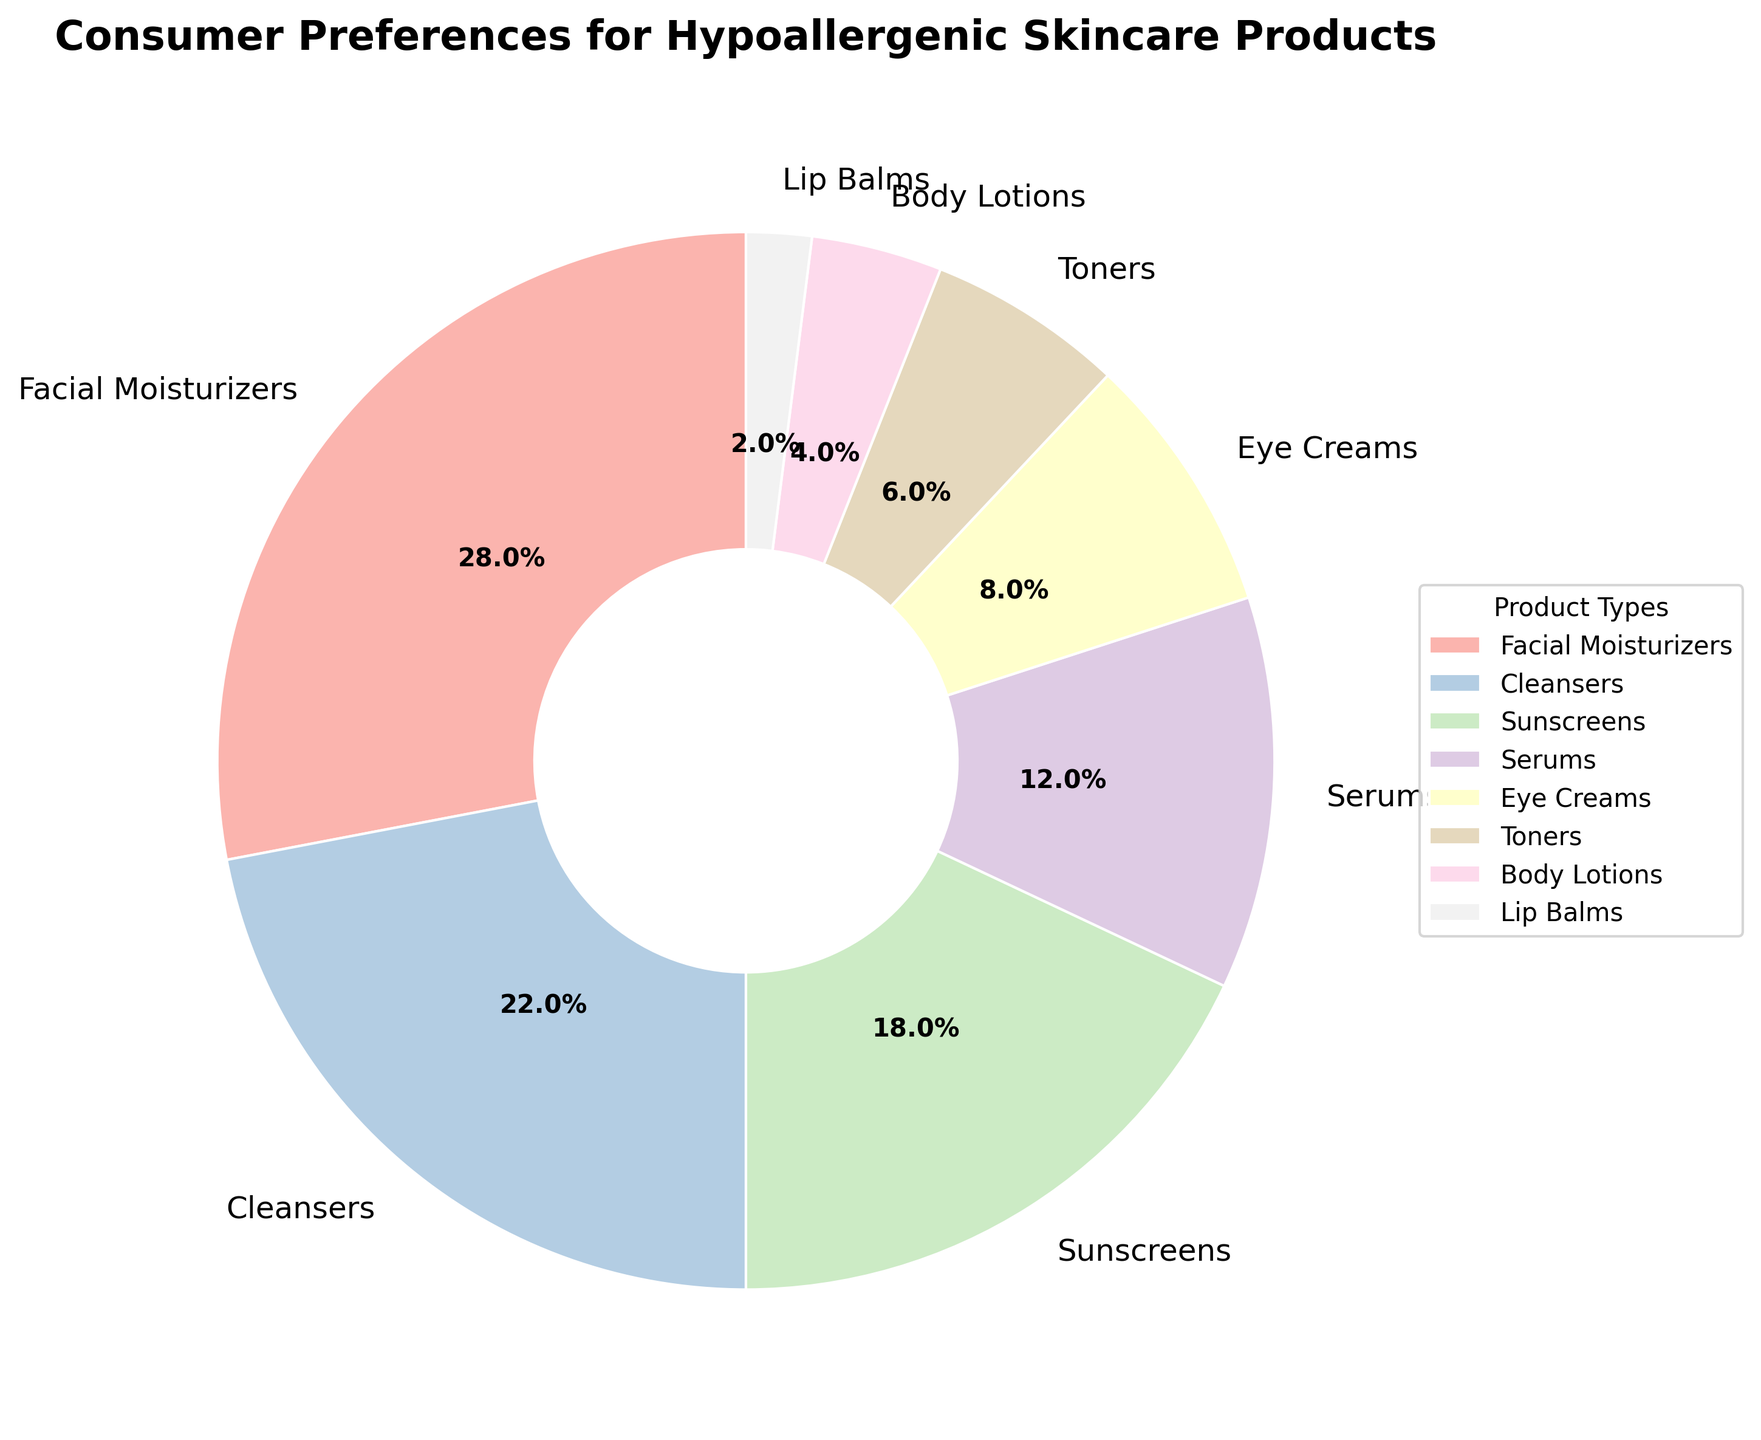Which product type has the highest consumer preference? The pie chart shows that Facial Moisturizers have the largest segment, indicated by the highest percentage of 28%.
Answer: Facial Moisturizers Which two product types have the smallest consumer preference and what are their combined percentages? Lip Balms and Body Lotions are the smallest segments with percentages of 2% and 4% respectively. Adding these gives 2% + 4% = 6%.
Answer: 6% How do the preferences for Cleansers and Serums compare? Cleansers have a segment labeled with 22%, while Serums have 12%. Therefore, Cleansers are more preferred than Serums.
Answer: Cleansers are more preferred What is the difference in consumer preference between Facial Moisturizers and Sunscreens? Facial Moisturizers are preferred by 28% of consumers, while Sunscreens are preferred by 18%. The difference is 28% - 18% = 10%.
Answer: 10% Which product types are preferred more than Eye Creams? The pie chart shows that Facial Moisturizers, Cleansers, Sunscreens, and Serums have higher percentages than Eye Creams, which have 8%.
Answer: Facial Moisturizers, Cleansers, Sunscreens, Serums Are Eye Creams more popular than Toners? Eye Creams show a preference percentage of 8%, while Toners show 6%. Therefore, Eye Creams are more popular than Toners.
Answer: Yes What percentage of consumers prefer Toners, Body Lotions, and Lip Balms combined? The preference percentages are 6% for Toners, 4% for Body Lotions, and 2% for Lip Balms. Adding these gives 6% + 4% + 2% = 12%.
Answer: 12% Which product types have a preference percentage of less than 10%? Eye Creams (8%), Toners (6%), Body Lotions (4%), and Lip Balms (2%) each have preference percentages of less than 10%.
Answer: Eye Creams, Toners, Body Lotions, Lip Balms 